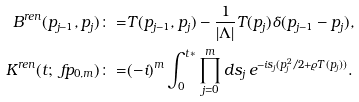<formula> <loc_0><loc_0><loc_500><loc_500>B ^ { r e n } ( p _ { j - 1 } , p _ { j } ) \colon = & T ( p _ { j - 1 } , p _ { j } ) - \frac { 1 } { | \Lambda | } T ( p _ { j } ) \delta ( p _ { j - 1 } - p _ { j } ) , \\ K ^ { r e n } ( t ; \ f p _ { 0 , m } ) \colon = & ( - i ) ^ { m } \int _ { 0 } ^ { t * } \prod _ { j = 0 } ^ { m } d s _ { j } \, e ^ { - i s _ { j } ( p _ { j } ^ { 2 } / 2 + \varrho T ( p _ { j } ) ) } .</formula> 